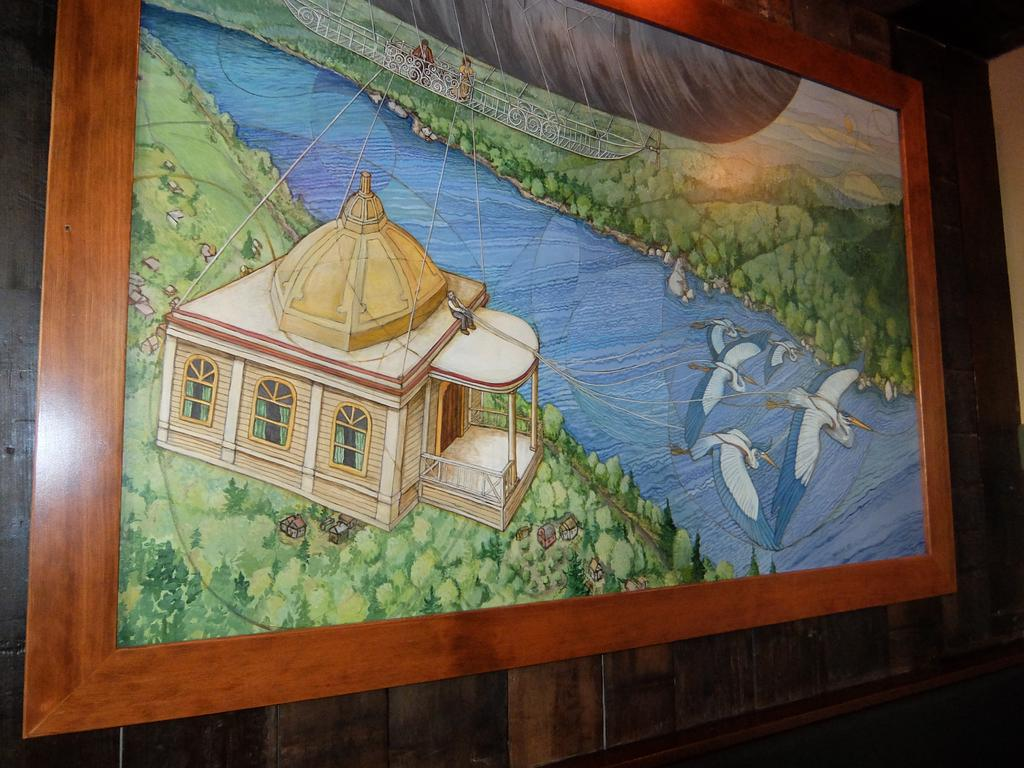What object can be seen in the image that is typically used for displaying photos? There is a photo frame in the image. Where is the photo frame located? The photo frame is on a wooden wall. What type of plant is growing inside the photo frame in the image? There is no plant growing inside the photo frame in the image; it is used for displaying photos. What type of locket can be seen hanging from the photo frame in the image? There is no locket present in the image; the photo frame is for displaying photos. 